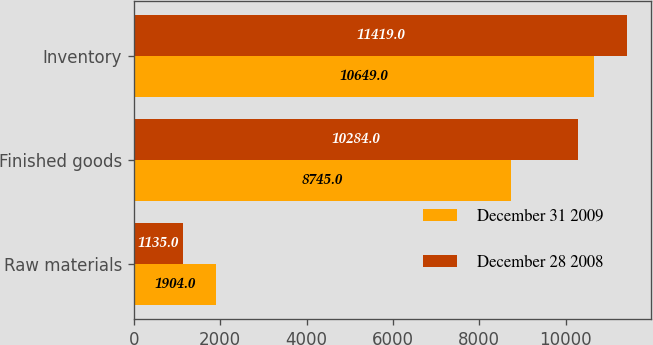<chart> <loc_0><loc_0><loc_500><loc_500><stacked_bar_chart><ecel><fcel>Raw materials<fcel>Finished goods<fcel>Inventory<nl><fcel>December 31 2009<fcel>1904<fcel>8745<fcel>10649<nl><fcel>December 28 2008<fcel>1135<fcel>10284<fcel>11419<nl></chart> 